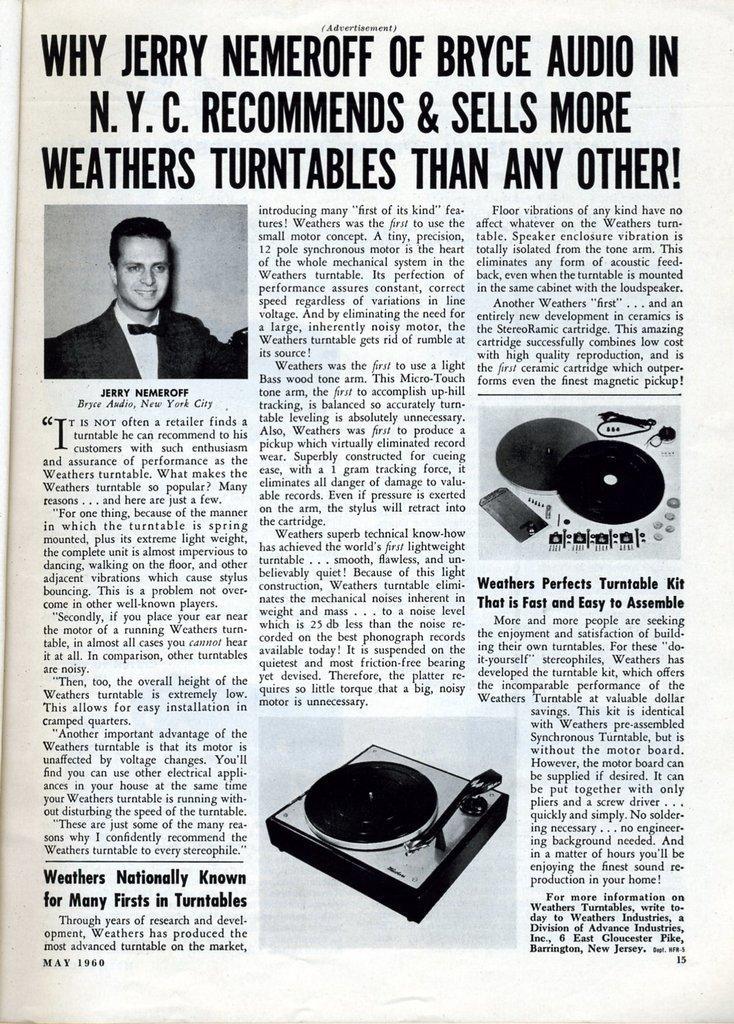Can you describe this image briefly? In this Image I can see a newspaper and something is written on it. I can see a person and few objects on the paper. 